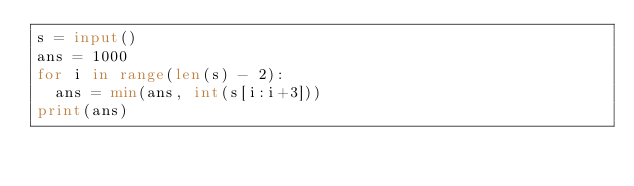<code> <loc_0><loc_0><loc_500><loc_500><_Python_>s = input()
ans = 1000
for i in range(len(s) - 2):
  ans = min(ans, int(s[i:i+3]))
print(ans)</code> 